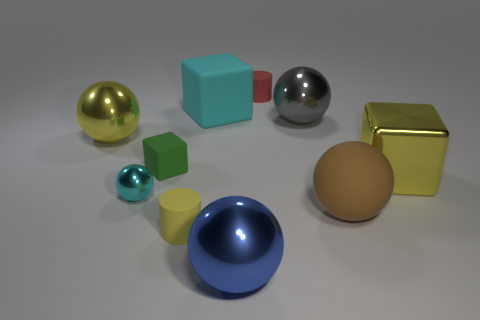Are there any patterns or consistencies in the objects? The objects follow a consistent theme of simple geometric shapes, each with a distinct, solid color. The arrangement and lighting seem deliberate, potentially highlighting the interplay of light, shadow, and the reflective properties of the objects' surfaces. Could these objects symbolize anything? While they could simply be a collection of shapes for a visual exercise, one might interpret them as a metaphor for individuality and diversity — each shape and color being unique but part of a greater whole. Alternatively, they could represent building blocks of learning in geometry or design. 